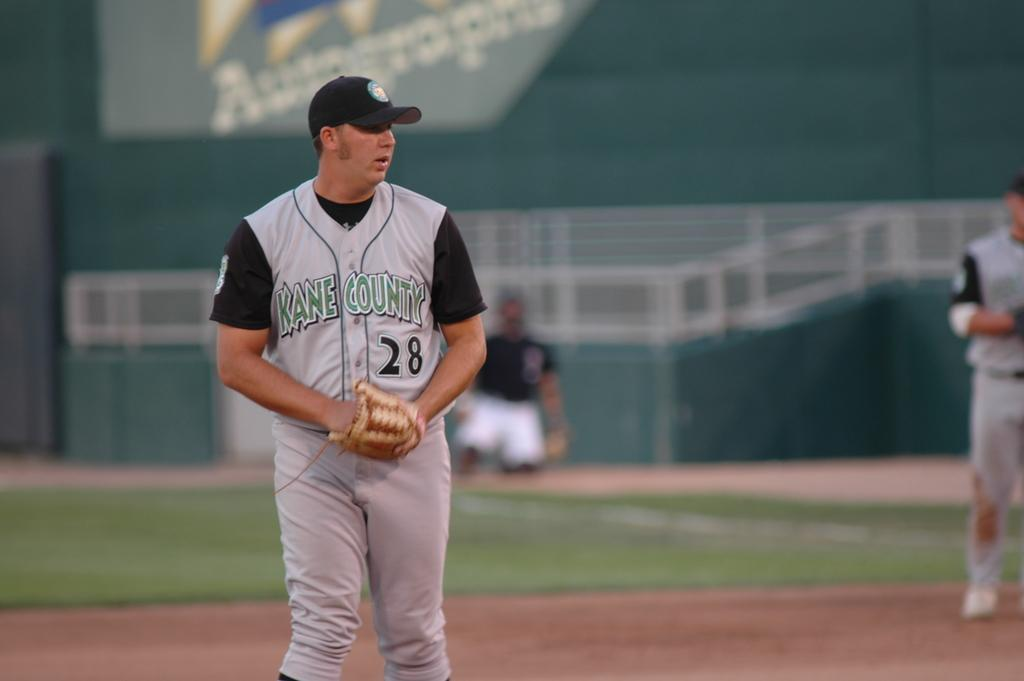<image>
Write a terse but informative summary of the picture. A man is wearing a Kane County jersey with the number 28 on it. 